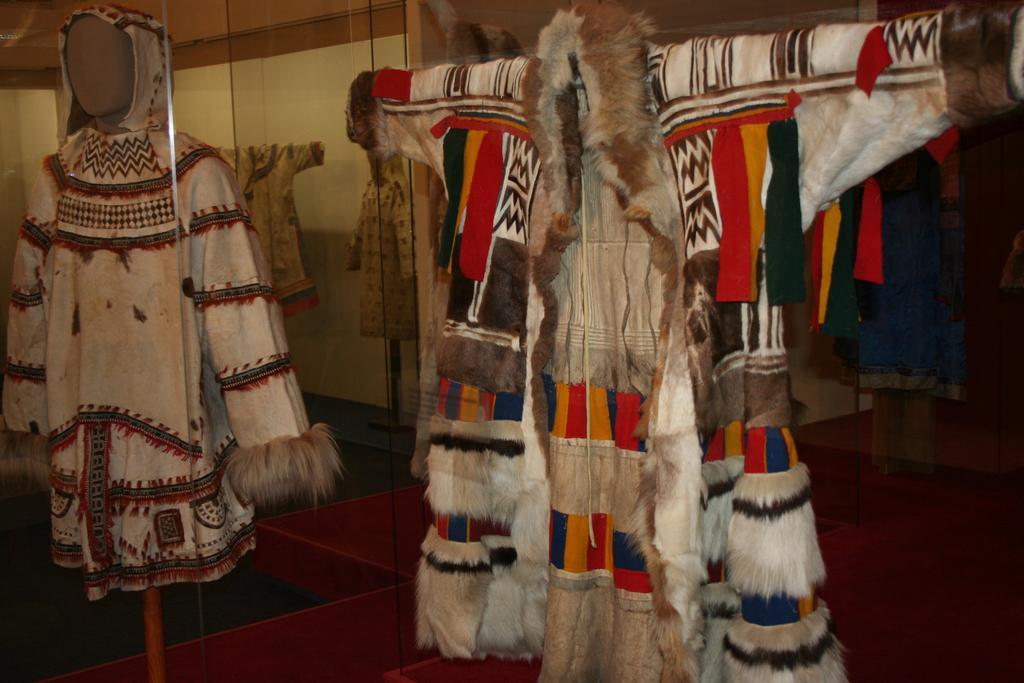Please provide a concise description of this image. In this image there are mannequins and we can see clothes placed on the mannequins. In the background there is a wall. At the bottom we can see a floor. 